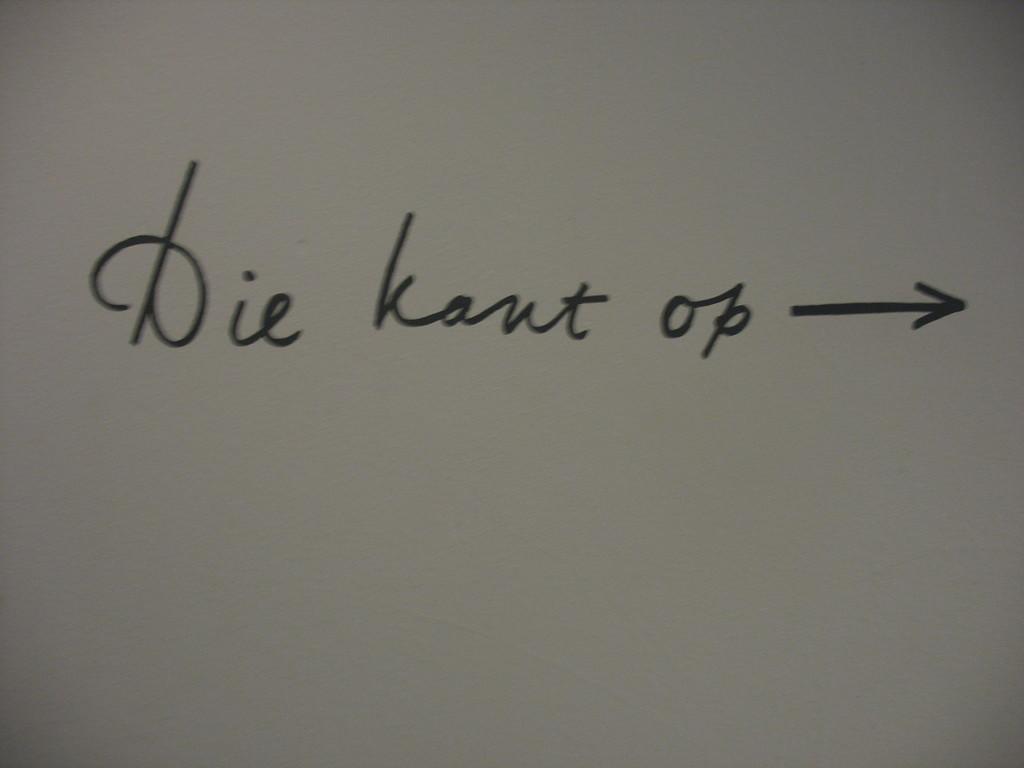What is the first word on the left?
Your answer should be very brief. Die. 